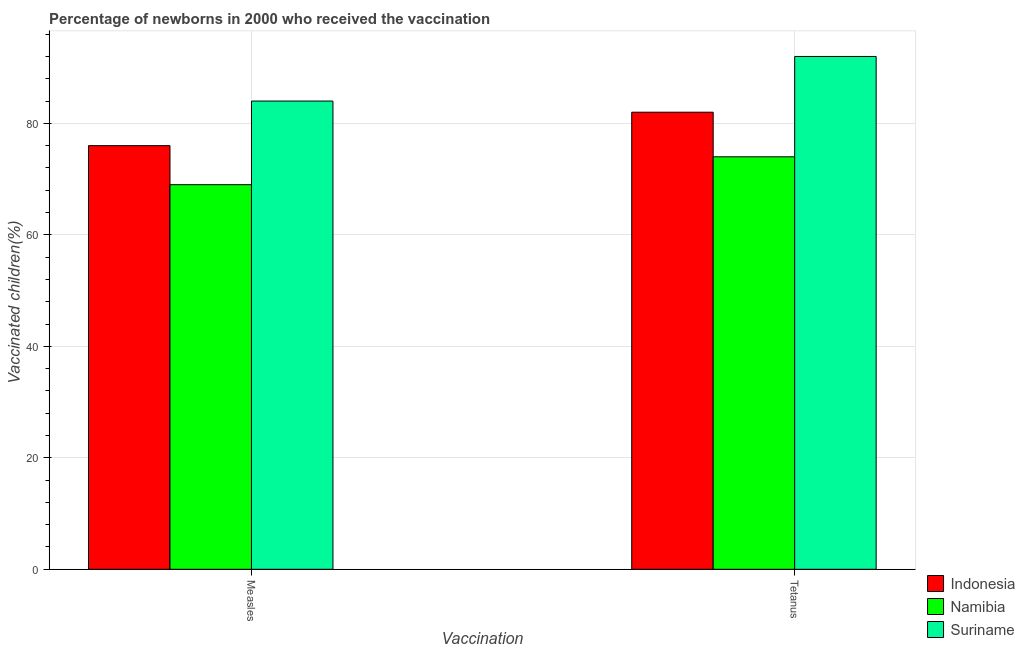How many different coloured bars are there?
Your answer should be compact. 3. How many bars are there on the 1st tick from the left?
Your answer should be compact. 3. What is the label of the 2nd group of bars from the left?
Make the answer very short. Tetanus. What is the percentage of newborns who received vaccination for tetanus in Namibia?
Offer a very short reply. 74. Across all countries, what is the maximum percentage of newborns who received vaccination for measles?
Offer a terse response. 84. Across all countries, what is the minimum percentage of newborns who received vaccination for measles?
Make the answer very short. 69. In which country was the percentage of newborns who received vaccination for measles maximum?
Provide a short and direct response. Suriname. In which country was the percentage of newborns who received vaccination for tetanus minimum?
Make the answer very short. Namibia. What is the total percentage of newborns who received vaccination for measles in the graph?
Your answer should be very brief. 229. What is the difference between the percentage of newborns who received vaccination for tetanus in Suriname and that in Namibia?
Provide a short and direct response. 18. What is the difference between the percentage of newborns who received vaccination for measles in Suriname and the percentage of newborns who received vaccination for tetanus in Namibia?
Your response must be concise. 10. What is the average percentage of newborns who received vaccination for measles per country?
Make the answer very short. 76.33. What is the difference between the percentage of newborns who received vaccination for measles and percentage of newborns who received vaccination for tetanus in Indonesia?
Give a very brief answer. -6. What is the ratio of the percentage of newborns who received vaccination for measles in Namibia to that in Indonesia?
Provide a short and direct response. 0.91. Is the percentage of newborns who received vaccination for measles in Suriname less than that in Indonesia?
Make the answer very short. No. What does the 1st bar from the left in Measles represents?
Offer a terse response. Indonesia. What does the 2nd bar from the right in Measles represents?
Ensure brevity in your answer.  Namibia. How many bars are there?
Your answer should be compact. 6. Are all the bars in the graph horizontal?
Provide a short and direct response. No. What is the difference between two consecutive major ticks on the Y-axis?
Your answer should be very brief. 20. Are the values on the major ticks of Y-axis written in scientific E-notation?
Your answer should be compact. No. Does the graph contain any zero values?
Ensure brevity in your answer.  No. Does the graph contain grids?
Your answer should be compact. Yes. How many legend labels are there?
Ensure brevity in your answer.  3. What is the title of the graph?
Keep it short and to the point. Percentage of newborns in 2000 who received the vaccination. Does "Middle income" appear as one of the legend labels in the graph?
Give a very brief answer. No. What is the label or title of the X-axis?
Offer a very short reply. Vaccination. What is the label or title of the Y-axis?
Your answer should be very brief. Vaccinated children(%)
. What is the Vaccinated children(%)
 in Indonesia in Tetanus?
Offer a very short reply. 82. What is the Vaccinated children(%)
 of Suriname in Tetanus?
Keep it short and to the point. 92. Across all Vaccination, what is the maximum Vaccinated children(%)
 in Indonesia?
Provide a short and direct response. 82. Across all Vaccination, what is the maximum Vaccinated children(%)
 of Namibia?
Provide a succinct answer. 74. Across all Vaccination, what is the maximum Vaccinated children(%)
 in Suriname?
Offer a terse response. 92. Across all Vaccination, what is the minimum Vaccinated children(%)
 in Indonesia?
Keep it short and to the point. 76. Across all Vaccination, what is the minimum Vaccinated children(%)
 of Namibia?
Keep it short and to the point. 69. Across all Vaccination, what is the minimum Vaccinated children(%)
 of Suriname?
Your answer should be compact. 84. What is the total Vaccinated children(%)
 of Indonesia in the graph?
Offer a terse response. 158. What is the total Vaccinated children(%)
 in Namibia in the graph?
Provide a succinct answer. 143. What is the total Vaccinated children(%)
 of Suriname in the graph?
Give a very brief answer. 176. What is the difference between the Vaccinated children(%)
 of Namibia in Measles and that in Tetanus?
Offer a terse response. -5. What is the difference between the Vaccinated children(%)
 in Suriname in Measles and that in Tetanus?
Make the answer very short. -8. What is the average Vaccinated children(%)
 in Indonesia per Vaccination?
Keep it short and to the point. 79. What is the average Vaccinated children(%)
 in Namibia per Vaccination?
Your answer should be very brief. 71.5. What is the average Vaccinated children(%)
 of Suriname per Vaccination?
Keep it short and to the point. 88. What is the ratio of the Vaccinated children(%)
 of Indonesia in Measles to that in Tetanus?
Your response must be concise. 0.93. What is the ratio of the Vaccinated children(%)
 in Namibia in Measles to that in Tetanus?
Keep it short and to the point. 0.93. What is the difference between the highest and the second highest Vaccinated children(%)
 in Namibia?
Ensure brevity in your answer.  5. What is the difference between the highest and the lowest Vaccinated children(%)
 in Namibia?
Your answer should be compact. 5. What is the difference between the highest and the lowest Vaccinated children(%)
 of Suriname?
Offer a terse response. 8. 